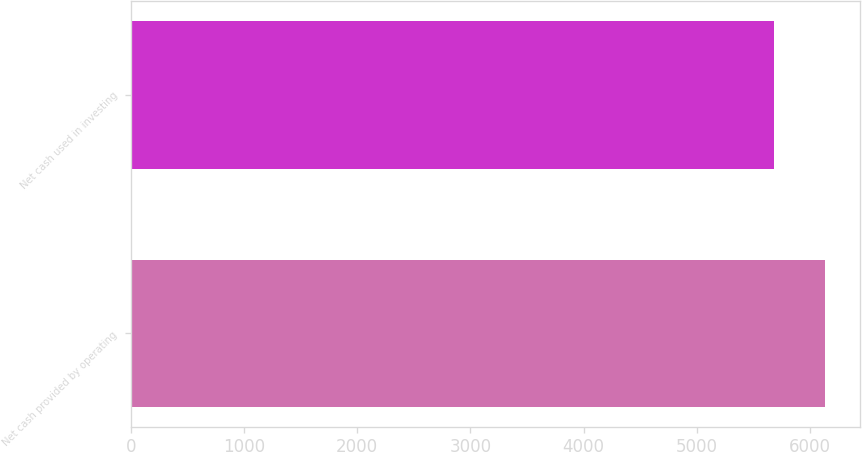Convert chart to OTSL. <chart><loc_0><loc_0><loc_500><loc_500><bar_chart><fcel>Net cash provided by operating<fcel>Net cash used in investing<nl><fcel>6135<fcel>5680<nl></chart> 